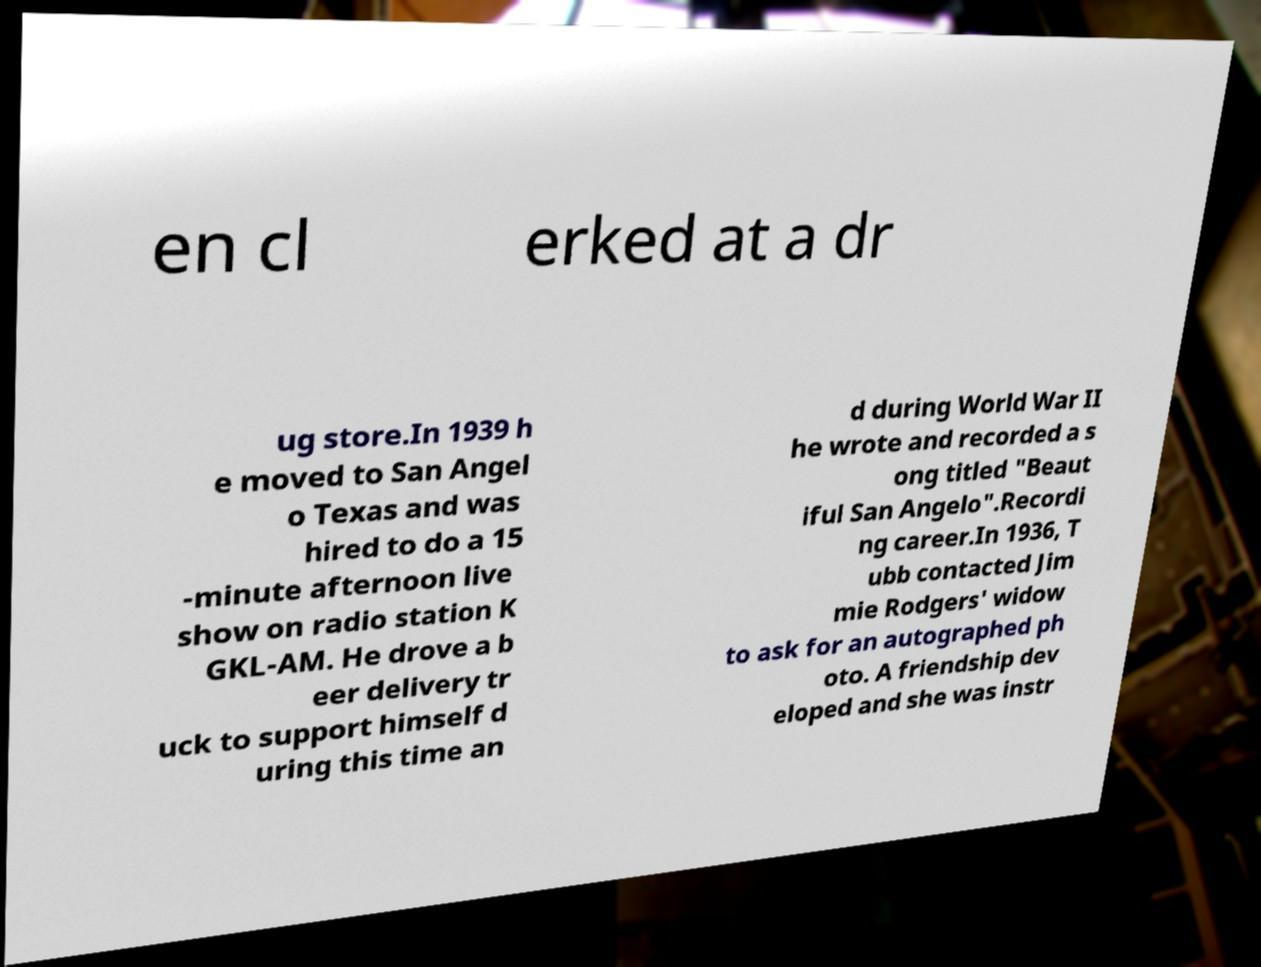Please read and relay the text visible in this image. What does it say? en cl erked at a dr ug store.In 1939 h e moved to San Angel o Texas and was hired to do a 15 -minute afternoon live show on radio station K GKL-AM. He drove a b eer delivery tr uck to support himself d uring this time an d during World War II he wrote and recorded a s ong titled "Beaut iful San Angelo".Recordi ng career.In 1936, T ubb contacted Jim mie Rodgers' widow to ask for an autographed ph oto. A friendship dev eloped and she was instr 